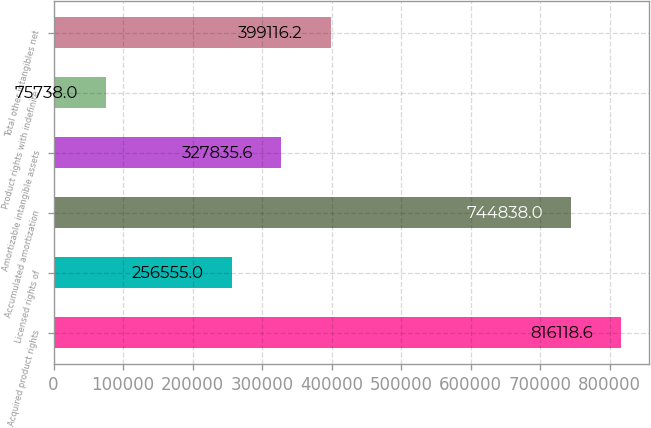Convert chart. <chart><loc_0><loc_0><loc_500><loc_500><bar_chart><fcel>Acquired product rights<fcel>Licensed rights of<fcel>Accumulated amortization<fcel>Amortizable intangible assets<fcel>Product rights with indefinite<fcel>Total other intangibles net<nl><fcel>816119<fcel>256555<fcel>744838<fcel>327836<fcel>75738<fcel>399116<nl></chart> 